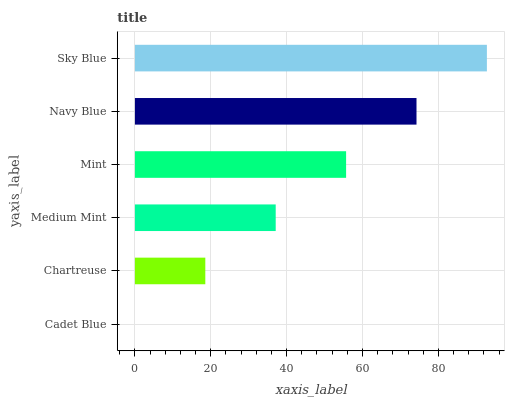Is Cadet Blue the minimum?
Answer yes or no. Yes. Is Sky Blue the maximum?
Answer yes or no. Yes. Is Chartreuse the minimum?
Answer yes or no. No. Is Chartreuse the maximum?
Answer yes or no. No. Is Chartreuse greater than Cadet Blue?
Answer yes or no. Yes. Is Cadet Blue less than Chartreuse?
Answer yes or no. Yes. Is Cadet Blue greater than Chartreuse?
Answer yes or no. No. Is Chartreuse less than Cadet Blue?
Answer yes or no. No. Is Mint the high median?
Answer yes or no. Yes. Is Medium Mint the low median?
Answer yes or no. Yes. Is Medium Mint the high median?
Answer yes or no. No. Is Cadet Blue the low median?
Answer yes or no. No. 